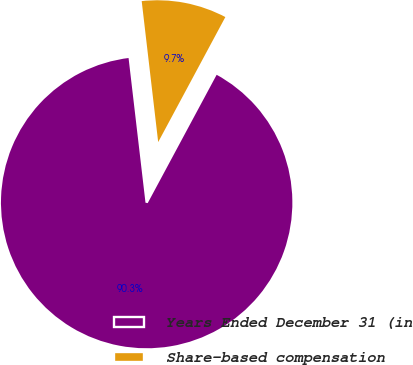Convert chart to OTSL. <chart><loc_0><loc_0><loc_500><loc_500><pie_chart><fcel>Years Ended December 31 (in<fcel>Share-based compensation<nl><fcel>90.3%<fcel>9.7%<nl></chart> 